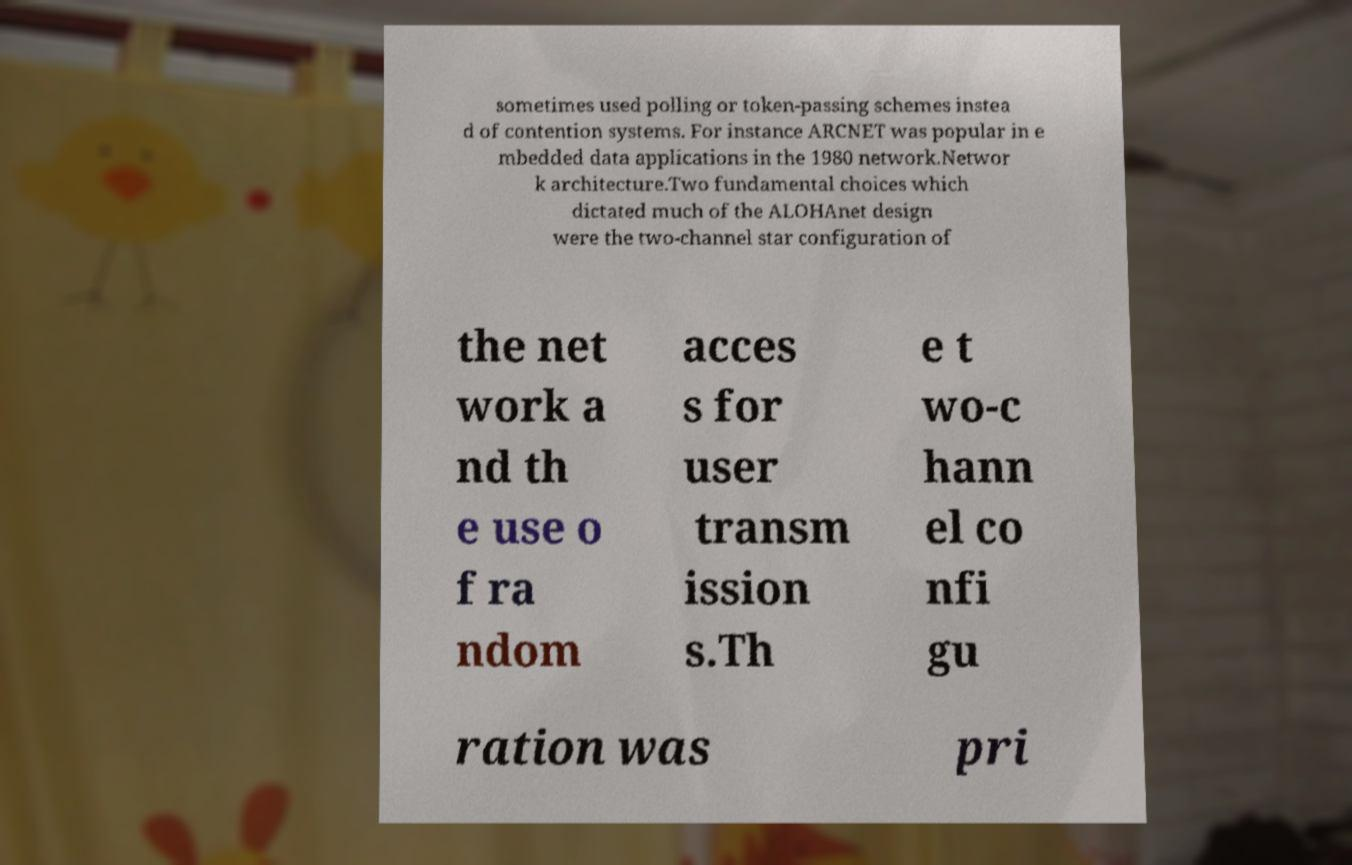Could you assist in decoding the text presented in this image and type it out clearly? sometimes used polling or token-passing schemes instea d of contention systems. For instance ARCNET was popular in e mbedded data applications in the 1980 network.Networ k architecture.Two fundamental choices which dictated much of the ALOHAnet design were the two-channel star configuration of the net work a nd th e use o f ra ndom acces s for user transm ission s.Th e t wo-c hann el co nfi gu ration was pri 